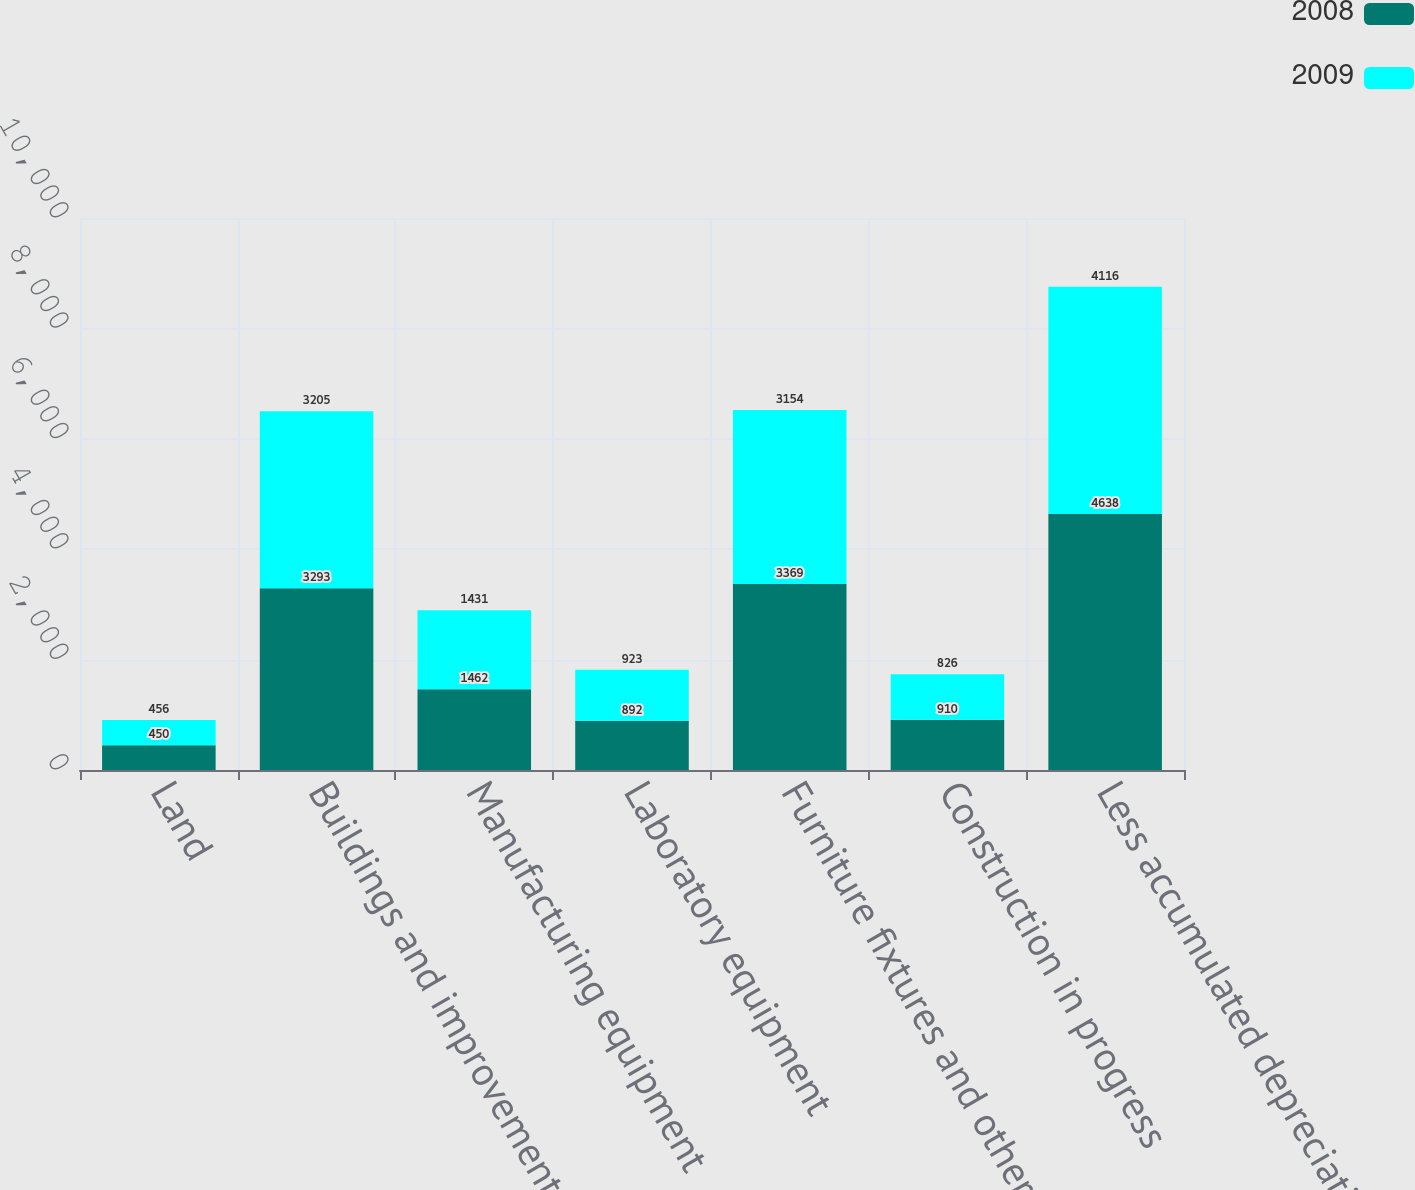Convert chart to OTSL. <chart><loc_0><loc_0><loc_500><loc_500><stacked_bar_chart><ecel><fcel>Land<fcel>Buildings and improvements<fcel>Manufacturing equipment<fcel>Laboratory equipment<fcel>Furniture fixtures and other<fcel>Construction in progress<fcel>Less accumulated depreciation<nl><fcel>2008<fcel>450<fcel>3293<fcel>1462<fcel>892<fcel>3369<fcel>910<fcel>4638<nl><fcel>2009<fcel>456<fcel>3205<fcel>1431<fcel>923<fcel>3154<fcel>826<fcel>4116<nl></chart> 